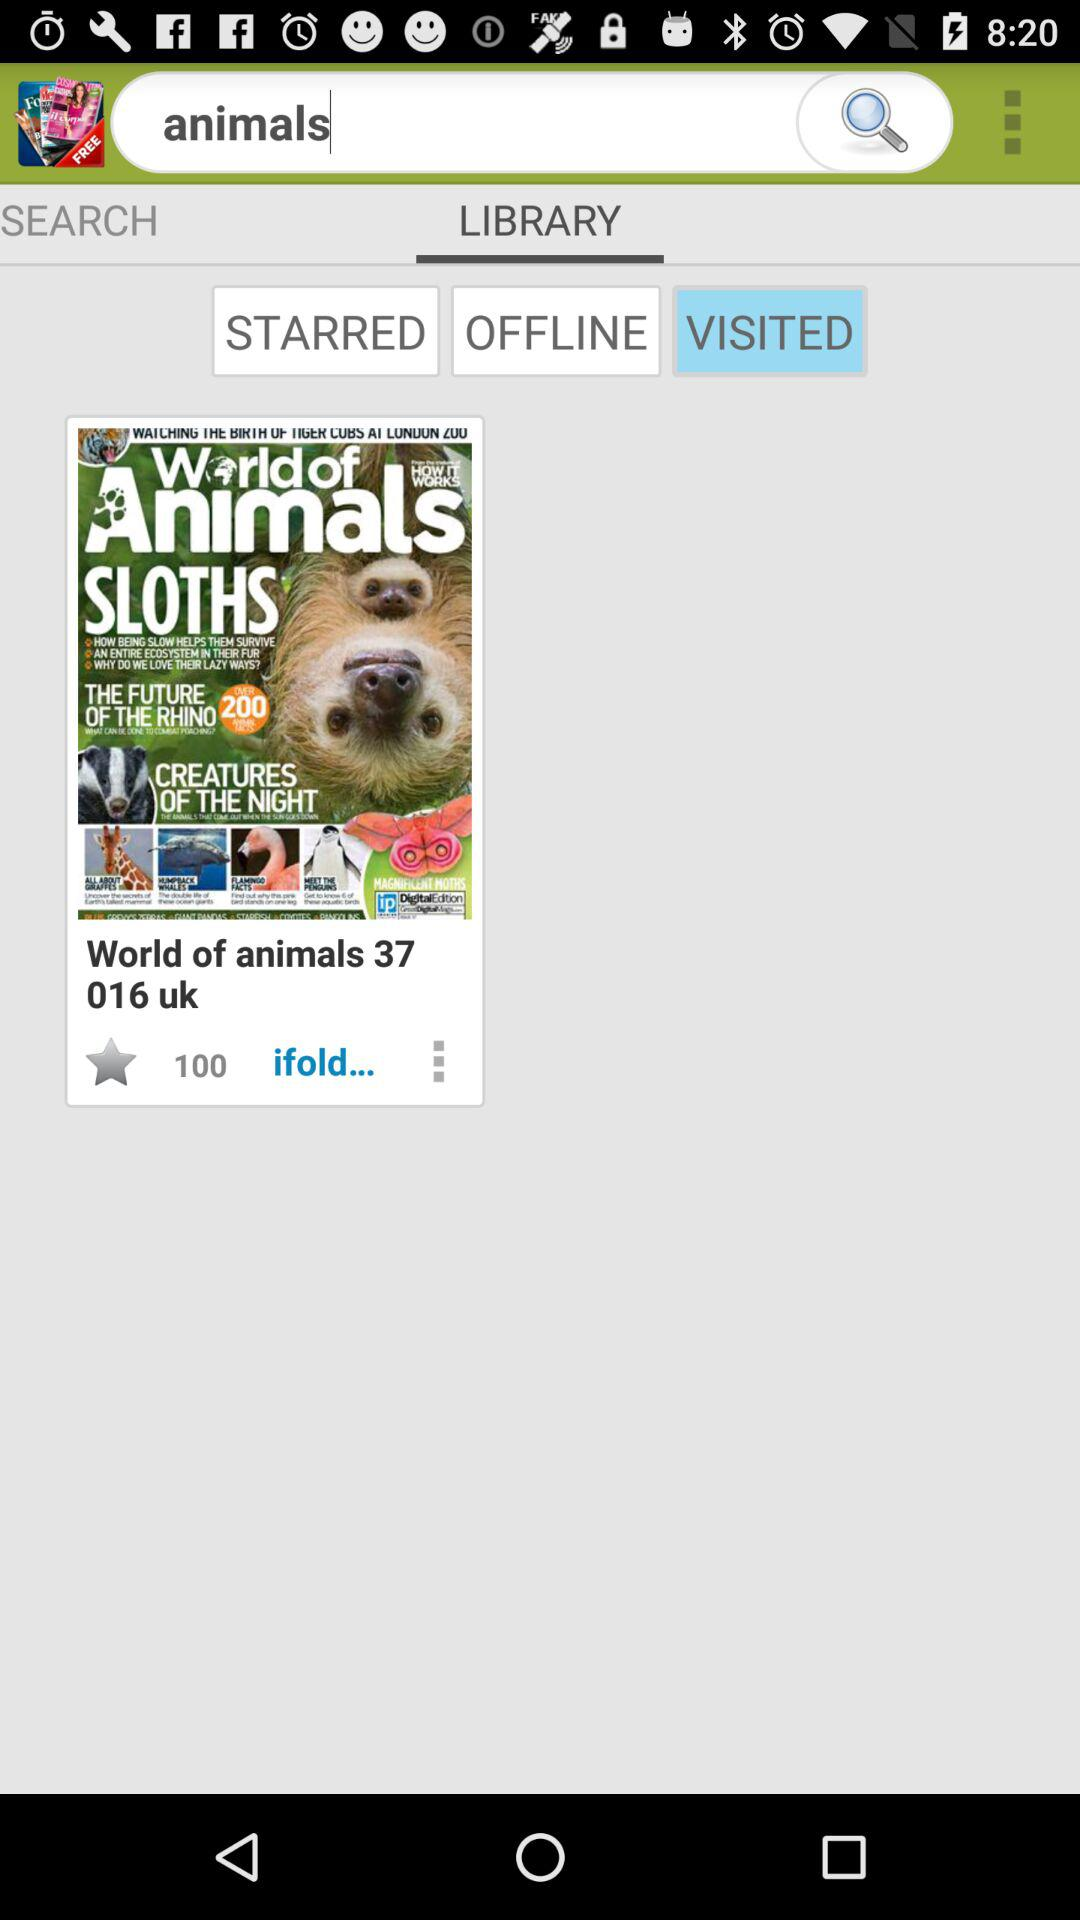What is the input? The input is animals. 